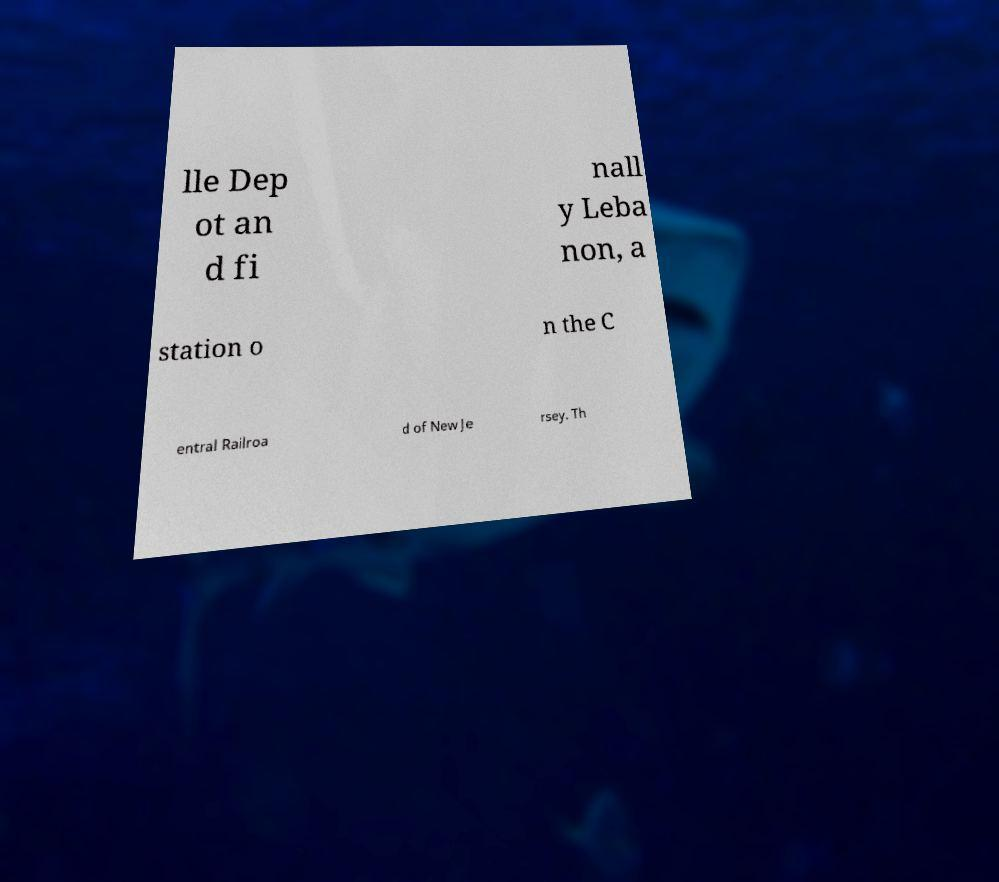Please identify and transcribe the text found in this image. lle Dep ot an d fi nall y Leba non, a station o n the C entral Railroa d of New Je rsey. Th 